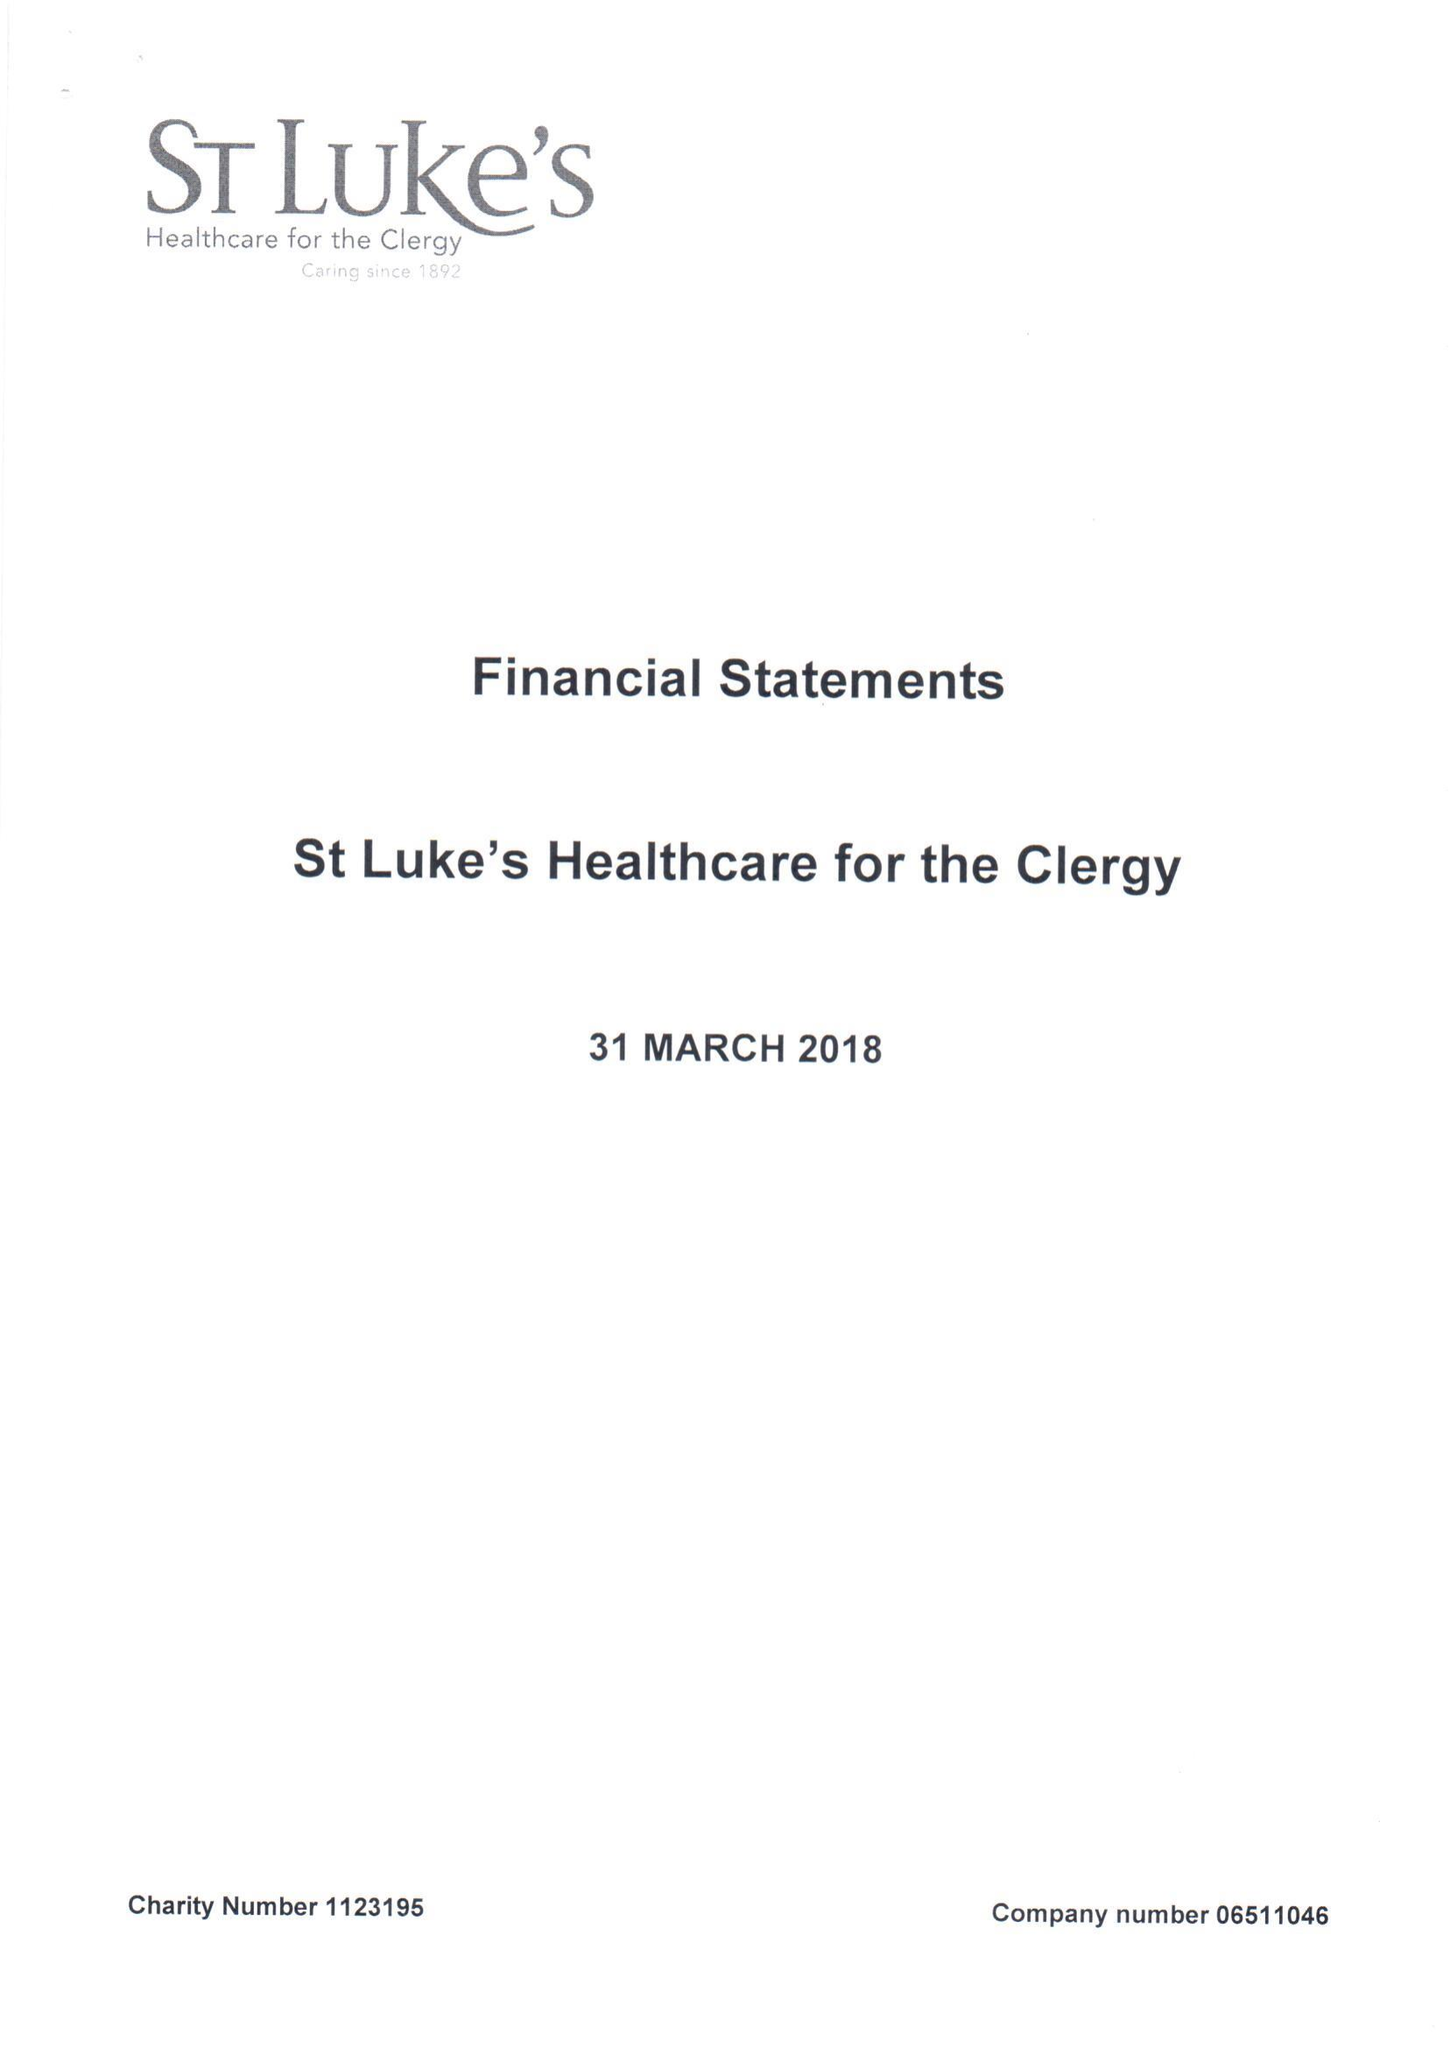What is the value for the spending_annually_in_british_pounds?
Answer the question using a single word or phrase. 500491.00 